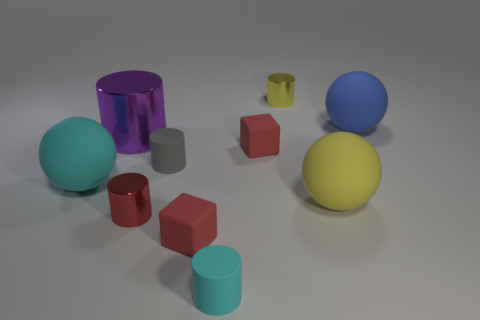Subtract all cubes. How many objects are left? 8 Subtract 1 gray cylinders. How many objects are left? 9 Subtract all blue spheres. Subtract all small red objects. How many objects are left? 6 Add 2 tiny red things. How many tiny red things are left? 5 Add 7 small red cylinders. How many small red cylinders exist? 8 